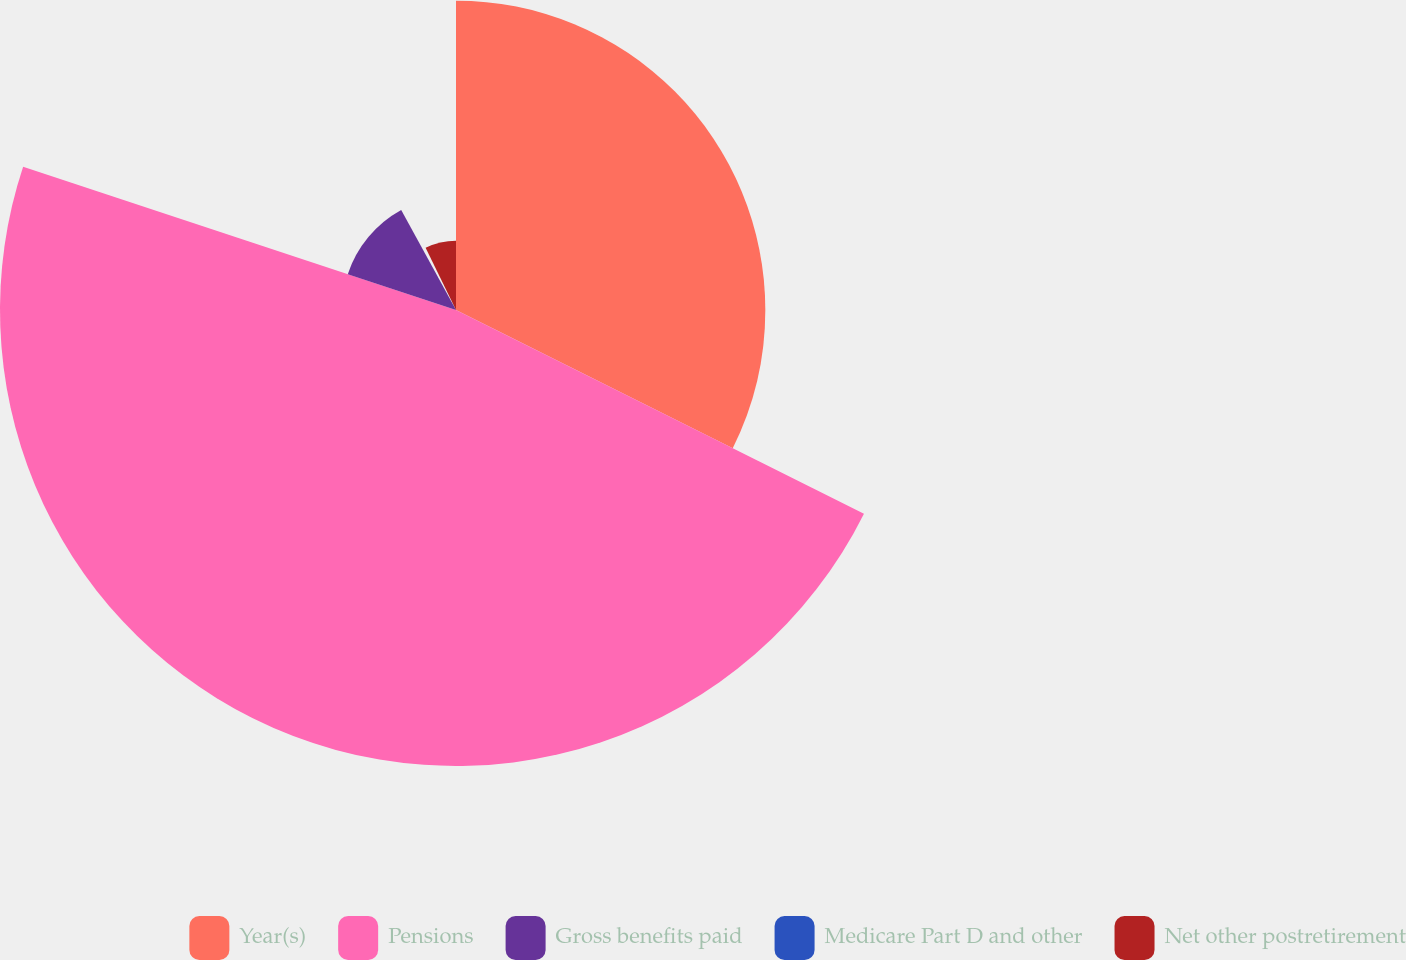Convert chart to OTSL. <chart><loc_0><loc_0><loc_500><loc_500><pie_chart><fcel>Year(s)<fcel>Pensions<fcel>Gross benefits paid<fcel>Medicare Part D and other<fcel>Net other postretirement<nl><fcel>32.37%<fcel>47.72%<fcel>11.93%<fcel>0.74%<fcel>7.24%<nl></chart> 